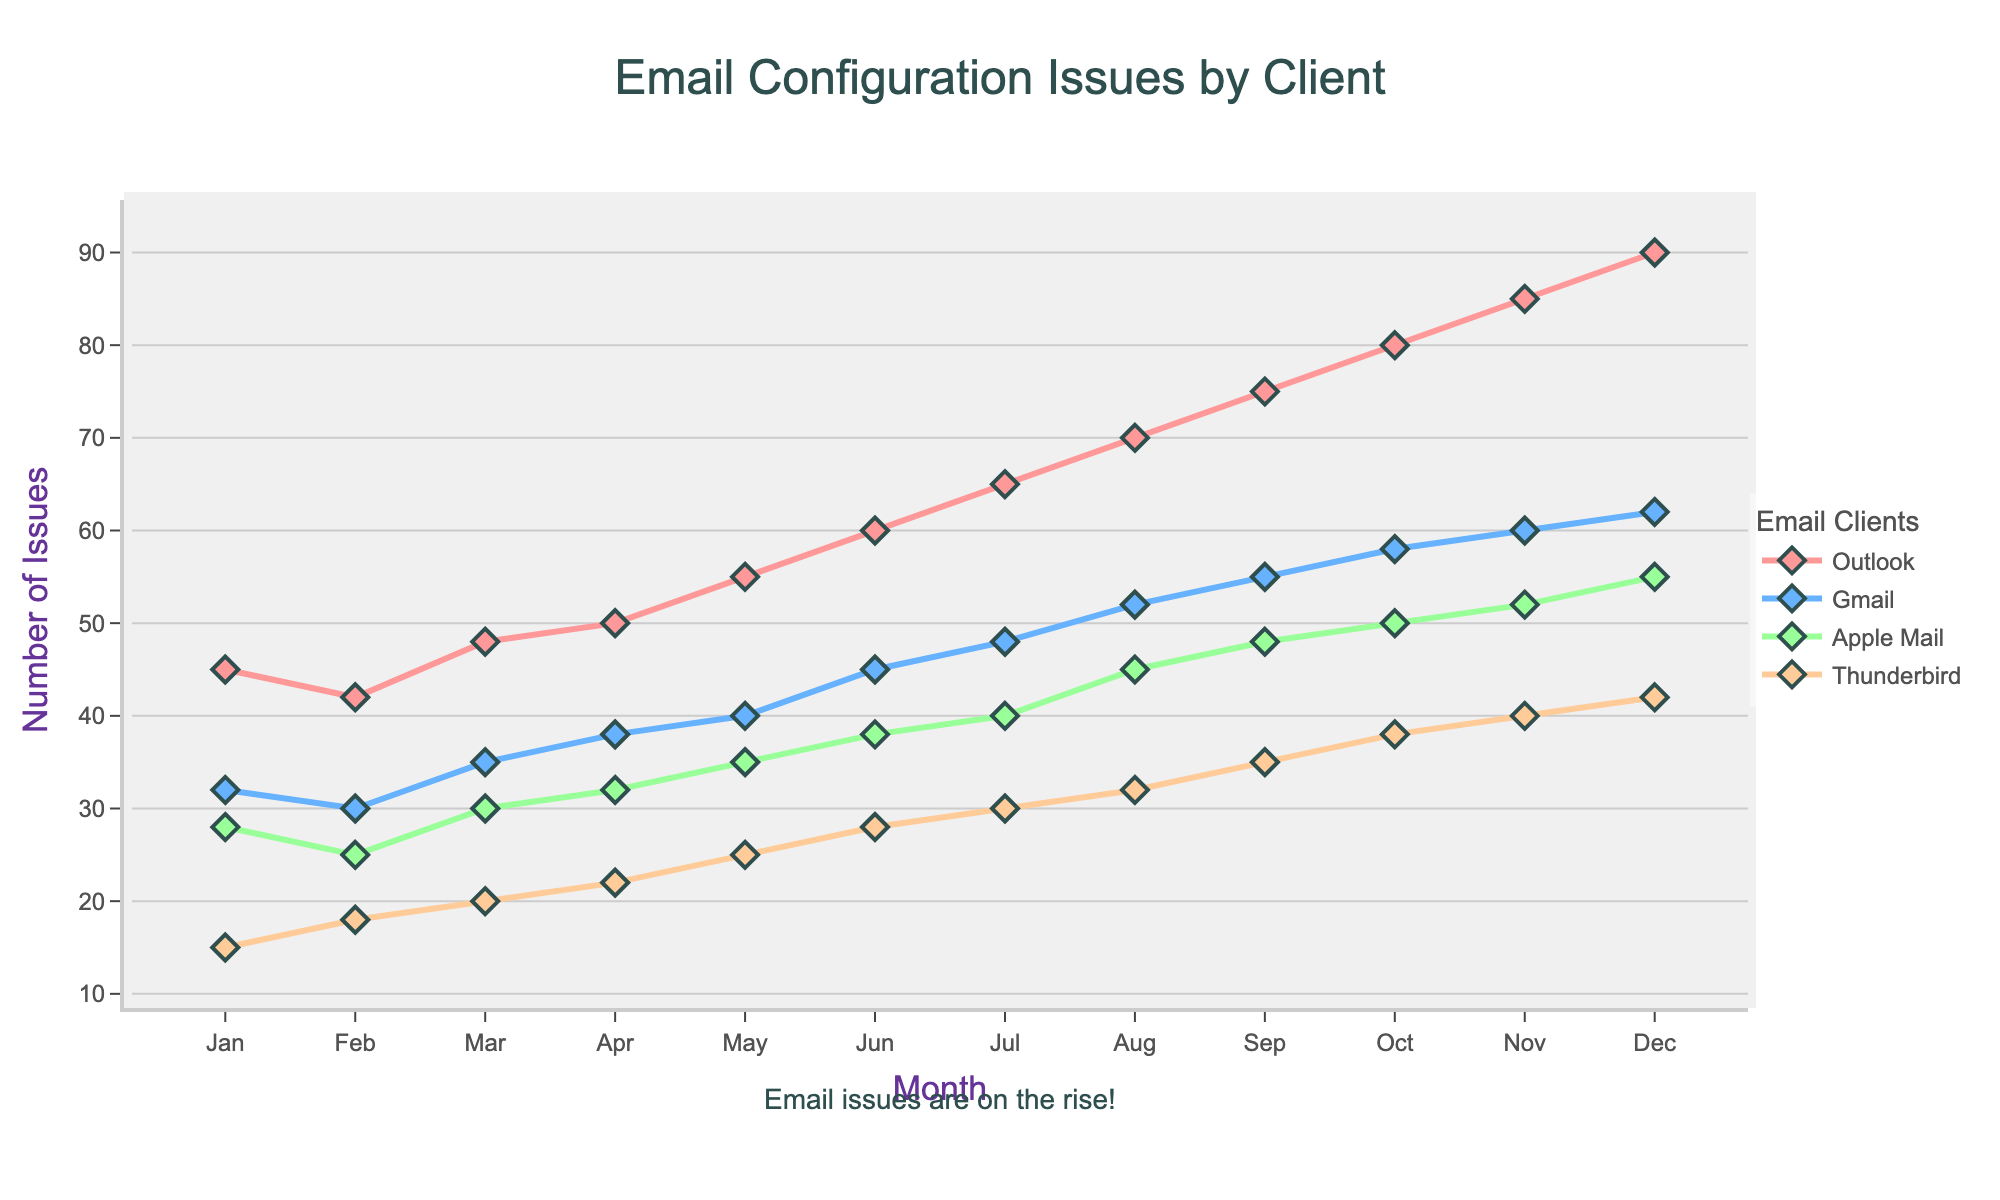Which email client reported the highest number of issues in December? Look at the values for December and identify the email client with the highest number of issues: Outlook (90), Gmail (62), Apple Mail (55), Thunderbird (42). Outlook has the highest value.
Answer: Outlook In which month did Apple Mail start reporting more than 30 issues? Find the first month where the value for Apple Mail exceeds 30. This happens in March.
Answer: March What is the total number of issues reported by all email clients in January? Sum up the values for January: Outlook (45) + Gmail (32) + Apple Mail (28) + Thunderbird (15) = 120.
Answer: 120 What is the average number of issues reported by Thunderbird over the entire year? Sum the values reported by Thunderbird for each month and divide by 12: (15 + 18 + 20 + 22 + 25 + 28 + 30 + 32 + 35 + 38 + 40 + 42) / 12 = 28.
Answer: 28 Which month saw the largest increase in issues for Gmail compared to the previous month? Calculate the monthly increase for Gmail and identify the largest: Jan-Feb (30-32=-2), Feb-Mar (35-30=5), Mar-Apr (38-35=3), Apr-May (40-38=2), May-Jun (45-40=5), Jun-Jul (48-45=3), Jul-Aug (52-48=4), Aug-Sep (55-52=3), Sep-Oct (58-55=3), Oct-Nov (60-58=2), Nov-Dec (62-60=2). The largest increase is 5, in both Feb-Mar and May-Jun.
Answer: February to March and May to June How many more issues were reported by Outlook compared to Thunderbird in July? Subtract Thunderbird's issues from Outlook's in July: Outlook (65) - Thunderbird (30) = 35.
Answer: 35 Across which months does the number of issues reported by Gmail consistently exceed those by Apple Mail? Identify months where Gmail's values are higher than Apple Mail's values: Every month from Jan to Dec, Gmail consistently has higher numbers (32, 30, 35, etc., compared to 28, 25, 30, etc.).
Answer: All months In October, compare the number of issues reported between Apple Mail and Thunderbird. Which has more? Look at the values for October: Apple Mail (50) and Thunderbird (38). Apple Mail has more issues.
Answer: Apple Mail How did the number of issues reported by Thunderbird change from June to July? Subtract June's value from July's value for Thunderbird: 30 - 28 = 2. The issues increased by 2.
Answer: Increased by 2 What is the trend in issues reported by Outlook over the year? Look at the values for Outlook from Jan to Dec: (45, 42, 48, 50, 55, 60, 65, 70, 75, 80, 85, 90). The numbers are consistently increasing.
Answer: Increasing 